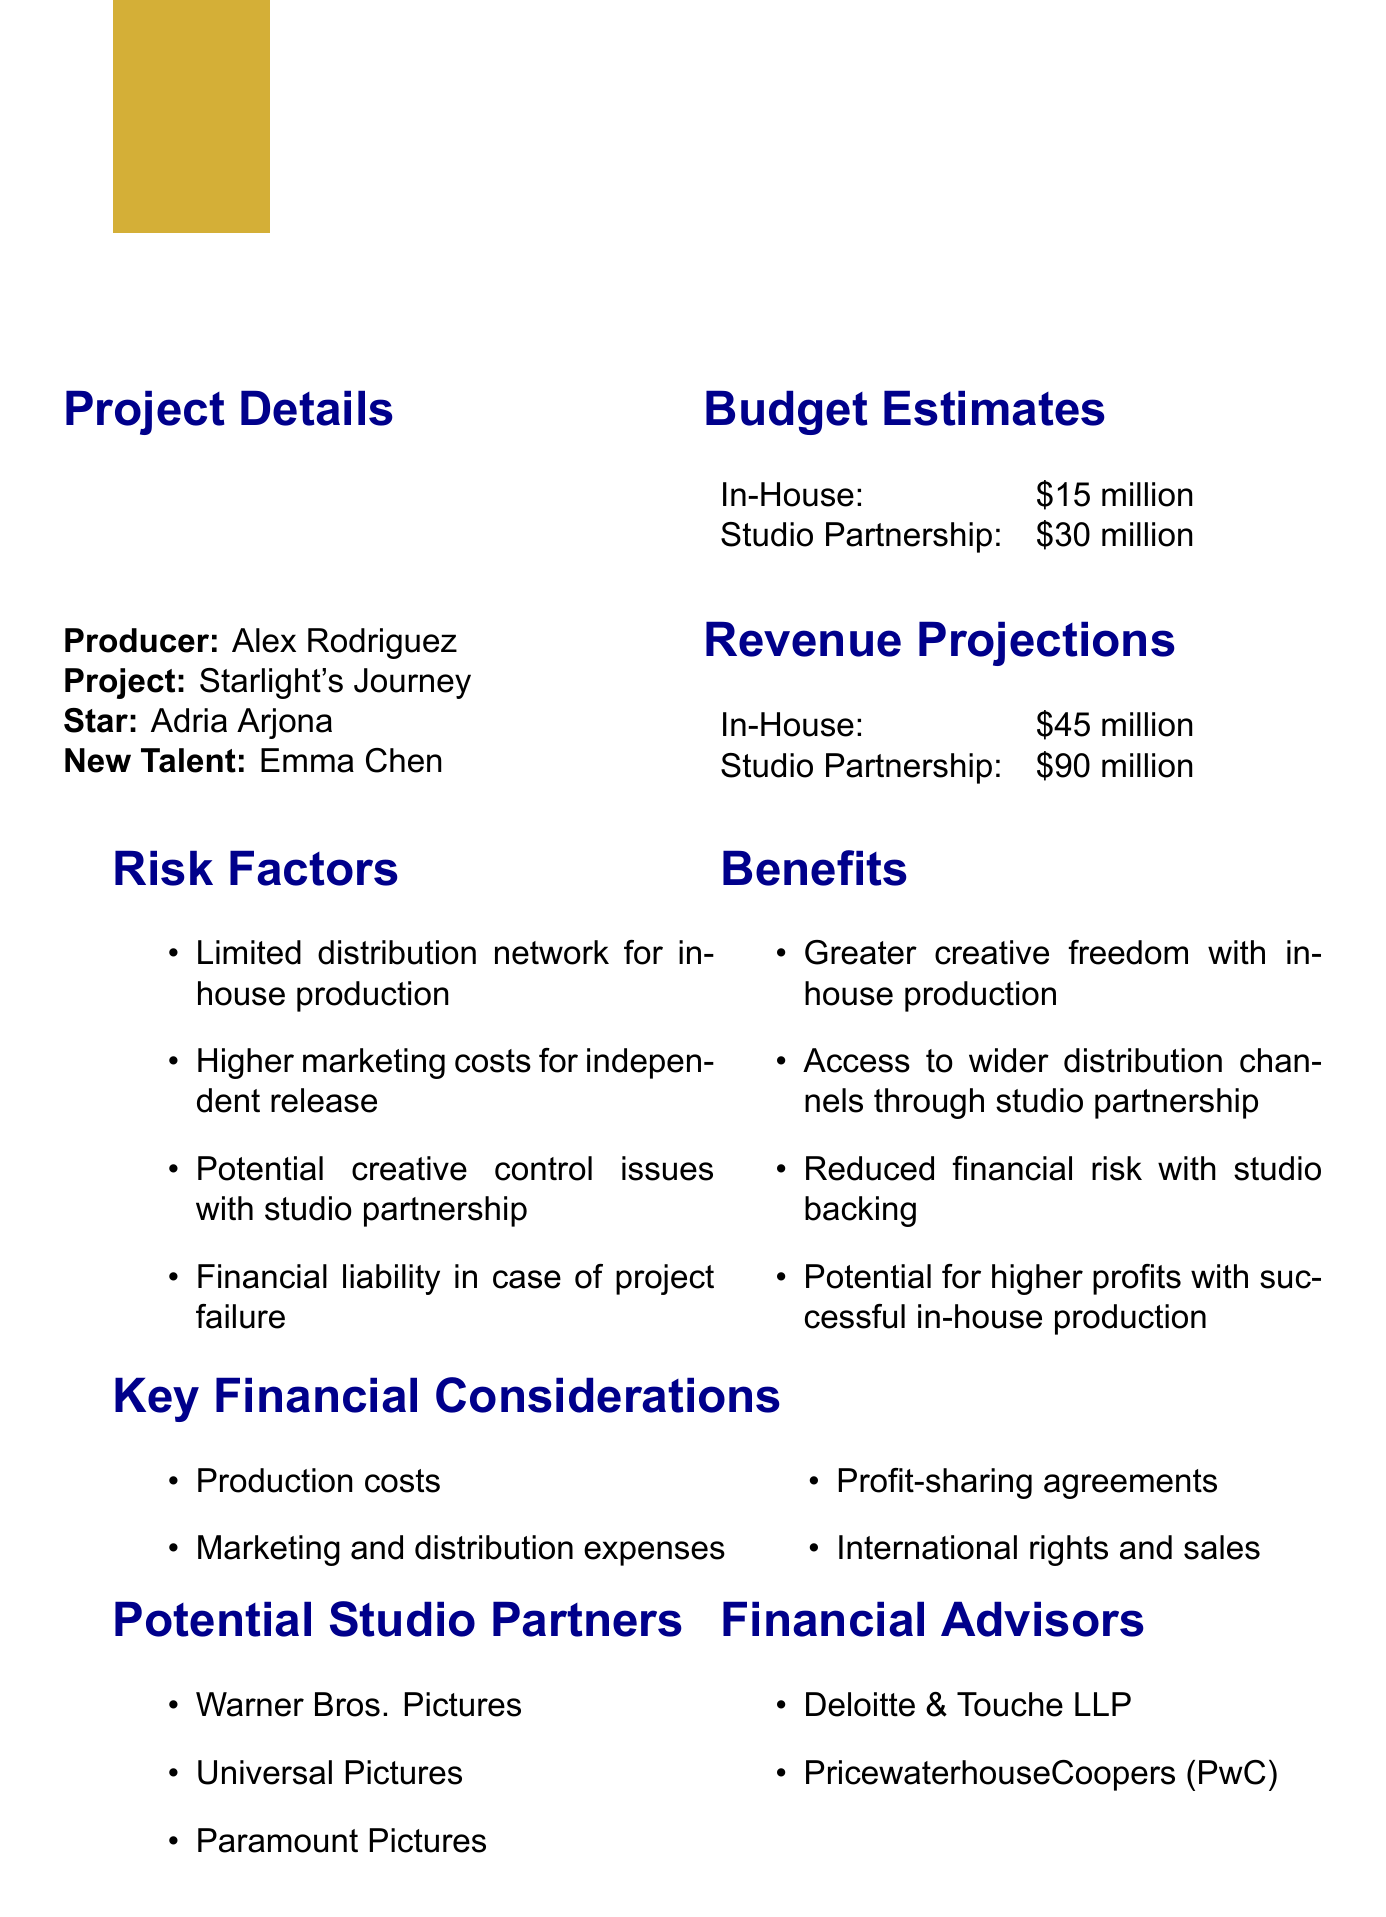What is the producer's name? The producer's name is explicitly mentioned in the document.
Answer: Alex Rodriguez What is the estimated budget for in-house production? The document provides budget estimates for both options clearly.
Answer: $15 million What are the revenue projections for studio partnership? Revenue projections are listed for both the in-house and studio partnership options.
Answer: $90 million What is the risk factor related to marketing costs? One of the risk factors discusses marketing expenses, which requires careful consideration.
Answer: Higher marketing costs for independent release Which potential studio partner is listed first? The potential studio partners are listed in a straightforward manner.
Answer: Warner Bros. Pictures How many benefits of in-house production are mentioned? The benefits of in-house production are enumerated in the document.
Answer: Four Who is the new talent in the project? The new talent associated with the project is explicitly mentioned in the details.
Answer: Emma Chen Which financial advisor is mentioned alongside Deloitte? The document lists financial advisors as part of the project structure.
Answer: PricewaterhouseCoopers (PwC) What is the primary benefit of a studio partnership regarding distribution? One of the benefits highlights distribution advantages of partnering with studios.
Answer: Access to wider distribution channels through studio partnership 